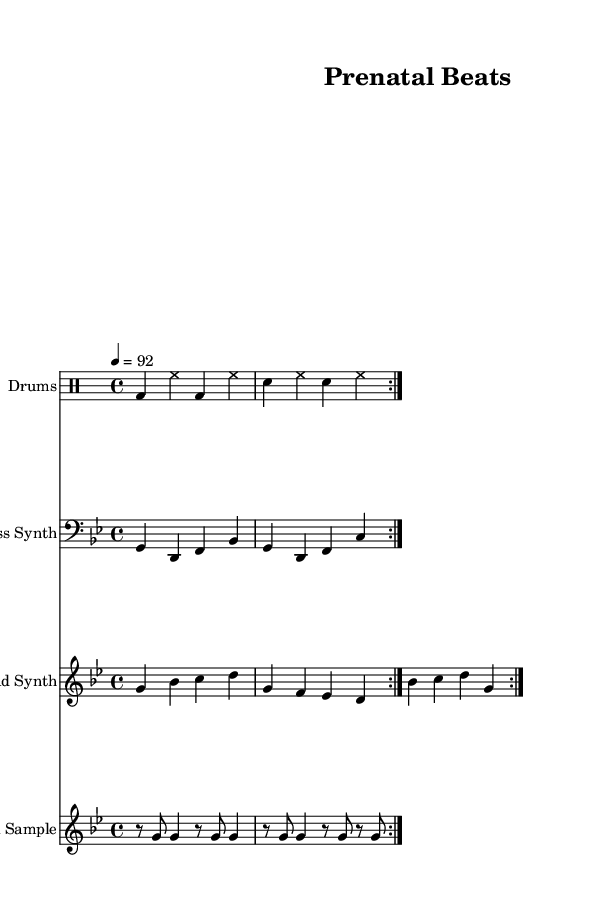What is the key signature of this music? The key signature is indicated by the sharps or flats at the beginning of the staff lines. In this sheet music, there are two flats, which corresponds to the key of G minor.
Answer: G minor What is the time signature of this music? The time signature is found at the beginning of the staff and indicates how many beats are in each measure. Here, it shows 4/4, meaning there are four beats in each measure.
Answer: 4/4 What is the tempo marking for this music? The tempo marking is written above the staff and specifies the speed of the music. In this case, it says "4 = 92," indicating that there are 92 beats per minute.
Answer: 92 How many measures are repeated in the vocal sample? The vocal sample section has a repeat sign indication, which shows that the measures should be repeated. In this part, there are two measures stated to be repeated.
Answer: 2 measures What type of instrument is indicated for the lead synth? The type of instrument is specified in the header of the staff. It states "Lead Synth," indicating that this part is intended for a synthesizer lead sound.
Answer: Lead Synth What is the rhythmic pattern used in the drums part? The drums part follows a specific pattern of bass drum and snare hits as indicated by the written notes. It is shown to have a consistent pattern of bass and snare drum hits with hi-hat accents, categorized in a repeated 4/4 rhythm.
Answer: Bass and snare hits What genre does this piece of music represent? The overall style and elements presented in the music, including the drum patterns, bass line, and vocal samples, reflect the characteristics typically associated with hip hop music.
Answer: Hip Hop 